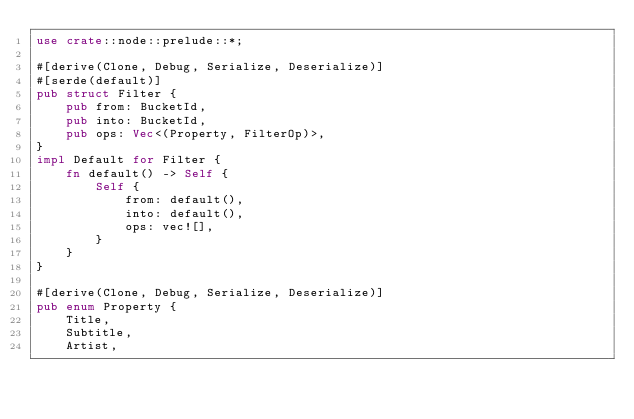Convert code to text. <code><loc_0><loc_0><loc_500><loc_500><_Rust_>use crate::node::prelude::*;

#[derive(Clone, Debug, Serialize, Deserialize)]
#[serde(default)]
pub struct Filter {
    pub from: BucketId,
    pub into: BucketId,
    pub ops: Vec<(Property, FilterOp)>,
}
impl Default for Filter {
    fn default() -> Self {
        Self {
            from: default(),
            into: default(),
            ops: vec![],
        }
    }
}

#[derive(Clone, Debug, Serialize, Deserialize)]
pub enum Property {
    Title,
    Subtitle,
    Artist,</code> 